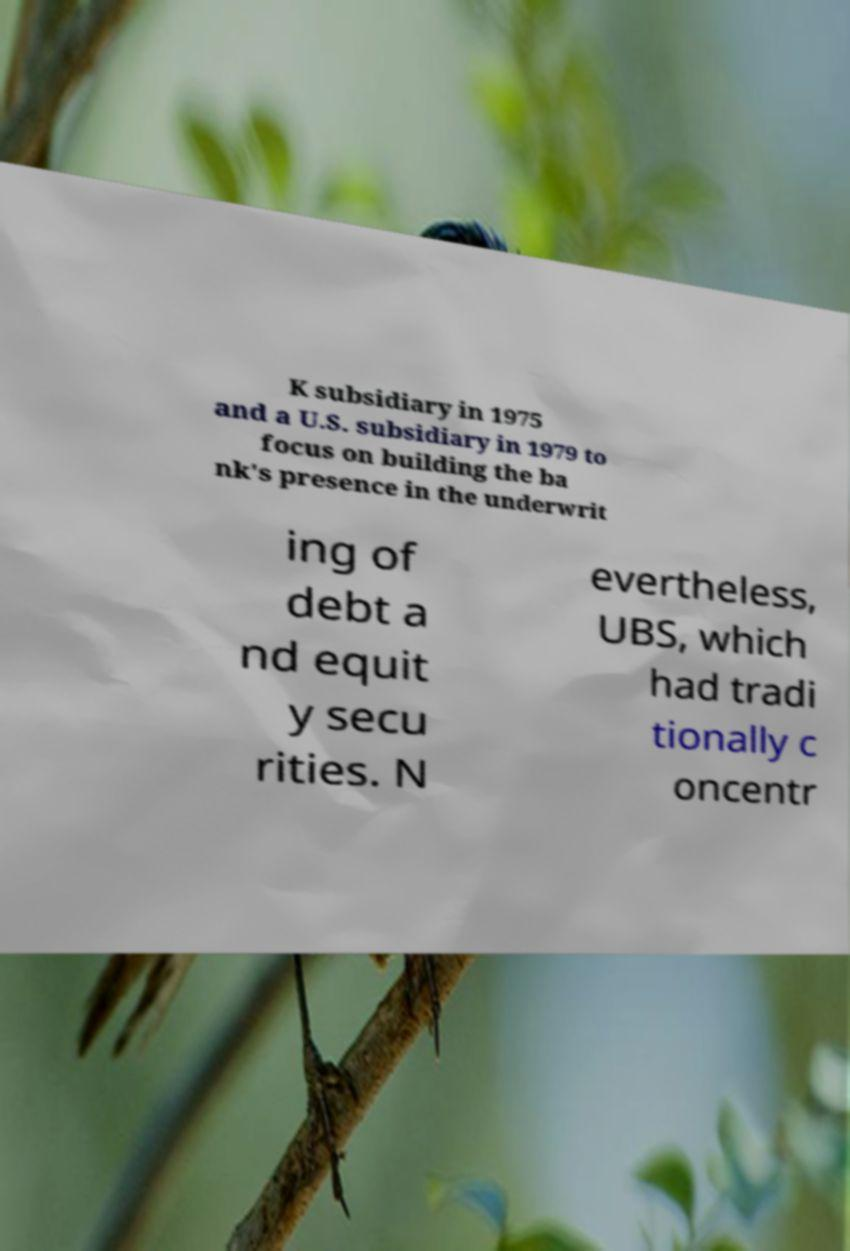Can you read and provide the text displayed in the image?This photo seems to have some interesting text. Can you extract and type it out for me? K subsidiary in 1975 and a U.S. subsidiary in 1979 to focus on building the ba nk's presence in the underwrit ing of debt a nd equit y secu rities. N evertheless, UBS, which had tradi tionally c oncentr 